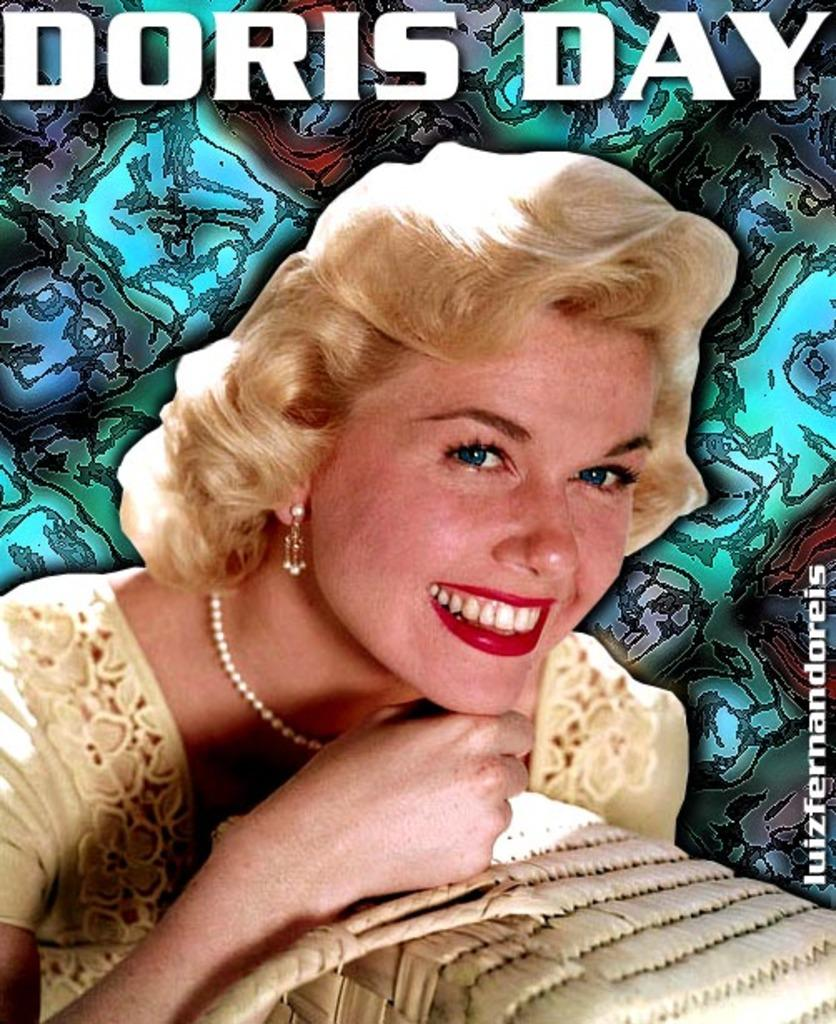What is the main subject of the image? The main subject of the image is a poster. What is depicted on the poster? The poster features a woman. Are there any words or letters on the poster? Yes, there is text on the poster. How many cats are sitting on the wall in the image? There are no cats or walls present in the image; it only features a poster with a woman and text. 